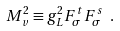Convert formula to latex. <formula><loc_0><loc_0><loc_500><loc_500>M _ { v } ^ { 2 } \equiv g _ { L } ^ { 2 } F _ { \sigma } ^ { t } F _ { \sigma } ^ { s } \ .</formula> 